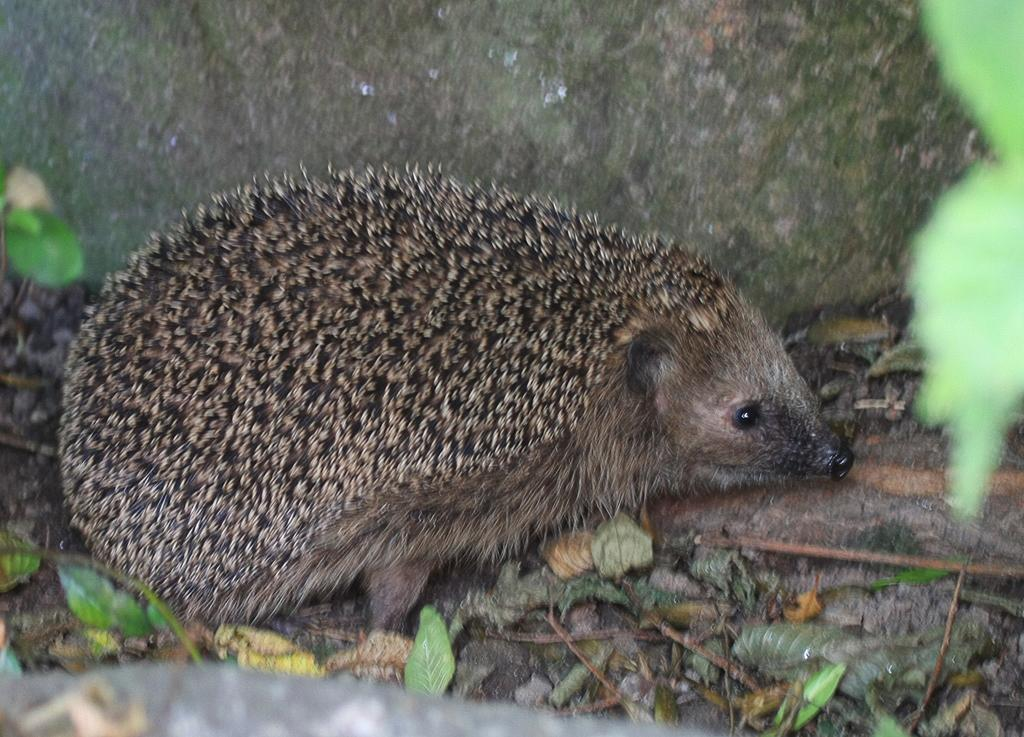What type of animal is in the image? The type of animal cannot be determined from the provided facts. Where is the animal located in relation to the wall? The animal is near a wall in the image. What type of vegetation is present in the image? There are leaves and stems in the image. What objects can be seen on a surface in the image? The objects on a surface cannot be determined from the provided facts. What idea does the animal have about love in the image? There is no indication in the image that the animal has any thoughts or ideas about love. 